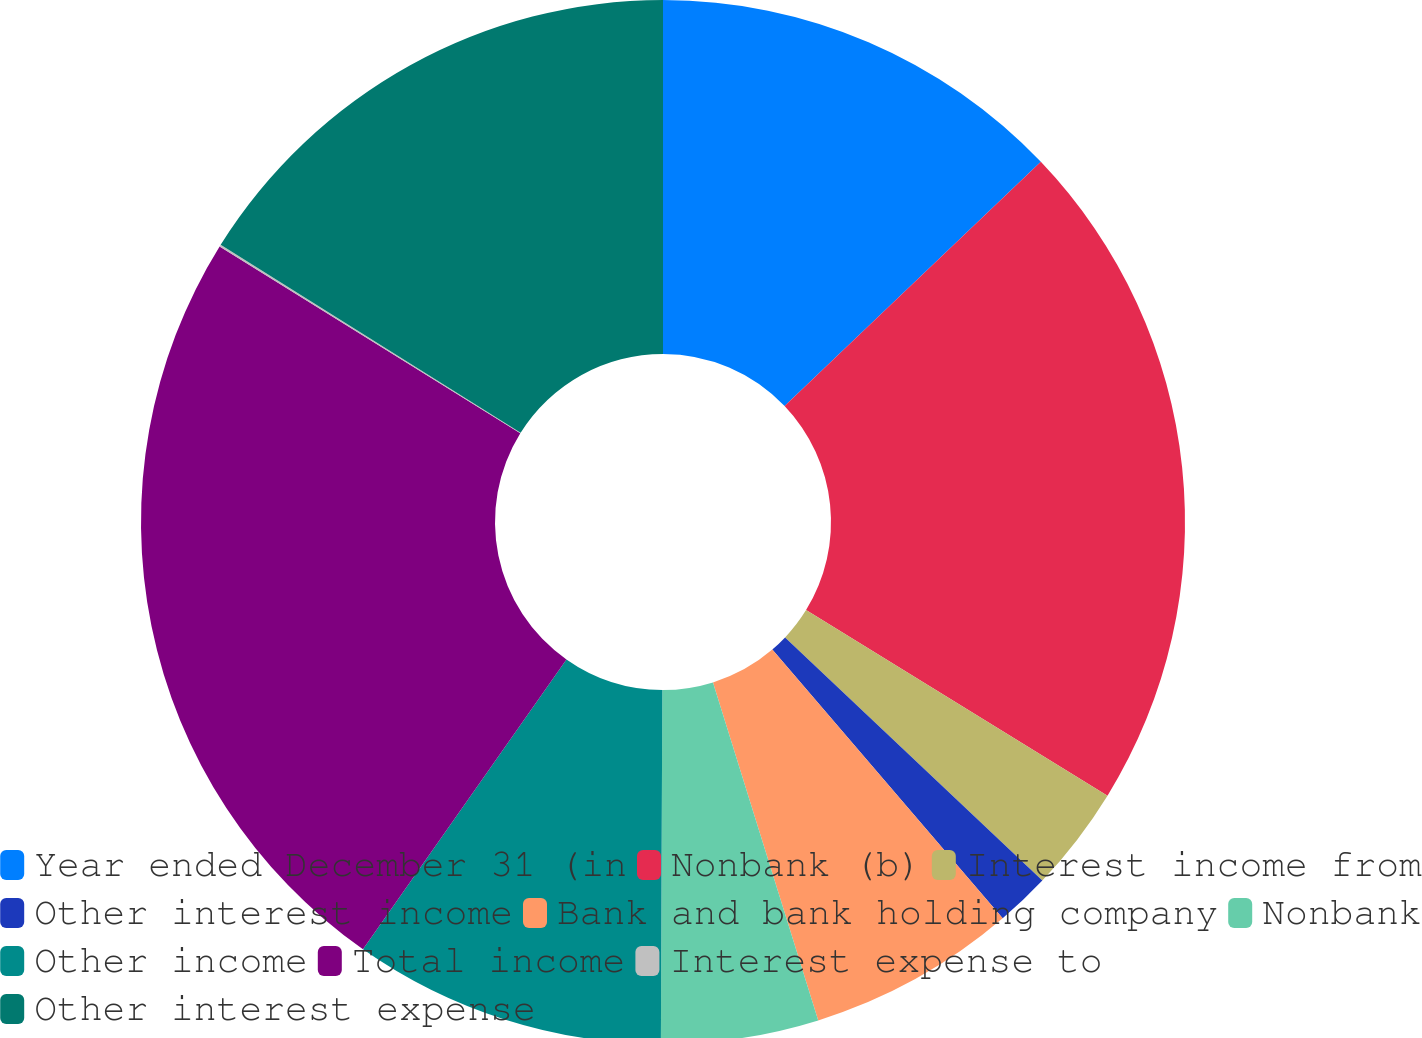<chart> <loc_0><loc_0><loc_500><loc_500><pie_chart><fcel>Year ended December 31 (in<fcel>Nonbank (b)<fcel>Interest income from<fcel>Other interest income<fcel>Bank and bank holding company<fcel>Nonbank<fcel>Other income<fcel>Total income<fcel>Interest expense to<fcel>Other interest expense<nl><fcel>12.88%<fcel>20.9%<fcel>3.27%<fcel>1.67%<fcel>6.47%<fcel>4.87%<fcel>9.68%<fcel>24.1%<fcel>0.06%<fcel>16.09%<nl></chart> 